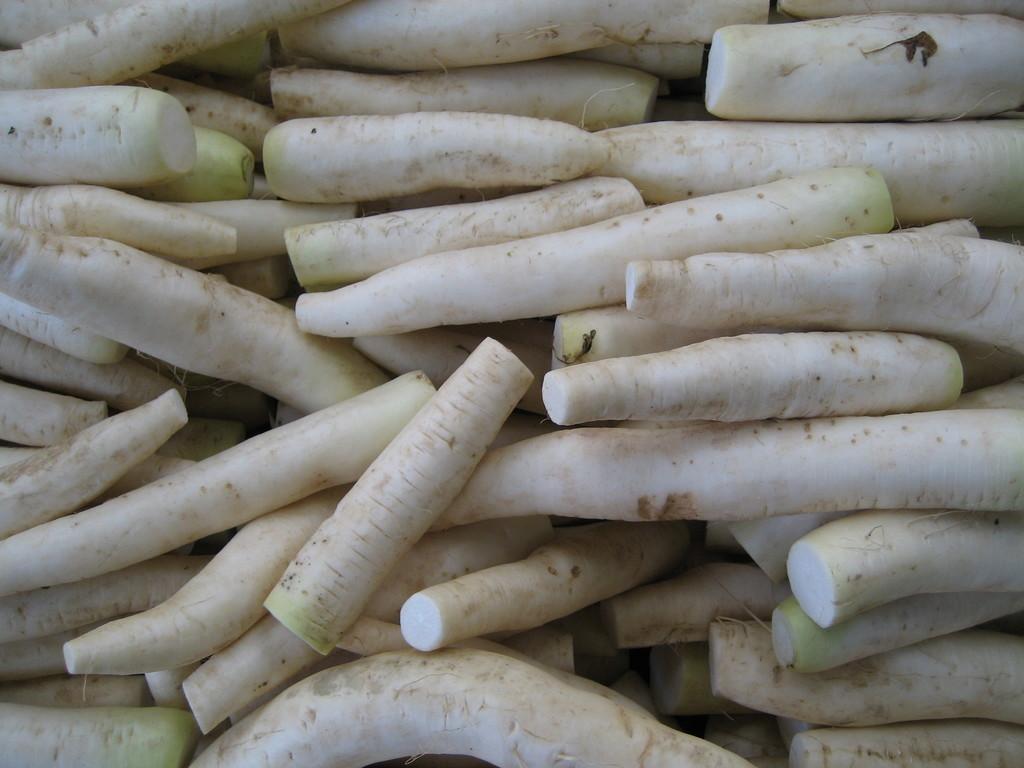Could you give a brief overview of what you see in this image? In this image there are so many radishes kept one beside the other. 